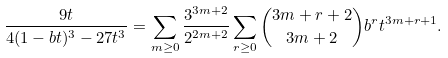Convert formula to latex. <formula><loc_0><loc_0><loc_500><loc_500>\frac { 9 t } { 4 ( 1 - b t ) ^ { 3 } - 2 7 t ^ { 3 } } & = \sum _ { m \geq 0 } \frac { 3 ^ { 3 m + 2 } } { 2 ^ { 2 m + 2 } } \sum _ { r \geq 0 } \binom { 3 m + r + 2 } { 3 m + 2 } b ^ { r } t ^ { 3 m + r + 1 } .</formula> 